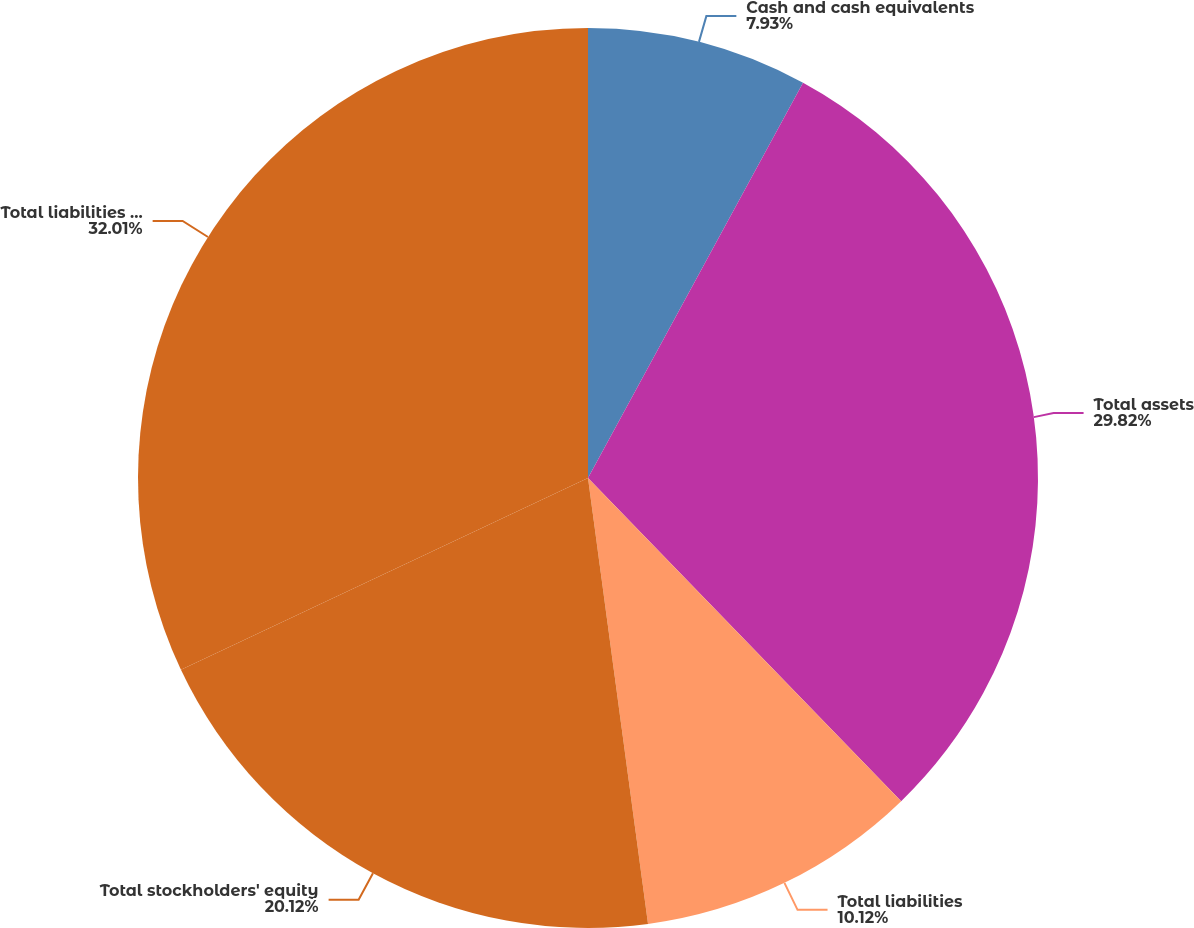Convert chart to OTSL. <chart><loc_0><loc_0><loc_500><loc_500><pie_chart><fcel>Cash and cash equivalents<fcel>Total assets<fcel>Total liabilities<fcel>Total stockholders' equity<fcel>Total liabilities redeemable<nl><fcel>7.93%<fcel>29.82%<fcel>10.12%<fcel>20.12%<fcel>32.01%<nl></chart> 